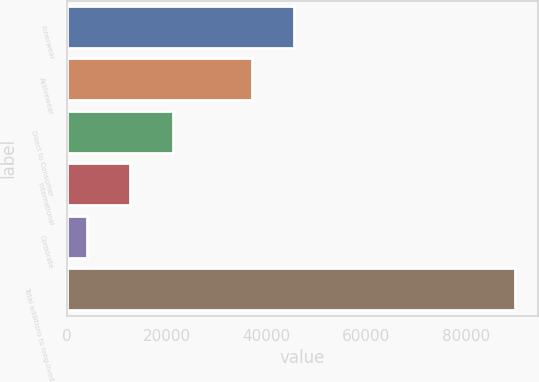Convert chart to OTSL. <chart><loc_0><loc_0><loc_500><loc_500><bar_chart><fcel>Innerwear<fcel>Activewear<fcel>Direct to Consumer<fcel>International<fcel>Corporate<fcel>Total additions to long-lived<nl><fcel>45617<fcel>37028<fcel>21250<fcel>12661<fcel>4072<fcel>89962<nl></chart> 